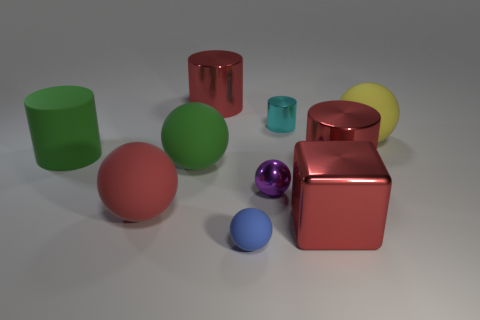Subtract 1 cylinders. How many cylinders are left? 3 Subtract all gray spheres. Subtract all green cylinders. How many spheres are left? 5 Subtract all cubes. How many objects are left? 9 Add 6 tiny gray matte objects. How many tiny gray matte objects exist? 6 Subtract 0 yellow blocks. How many objects are left? 10 Subtract all tiny red spheres. Subtract all red cylinders. How many objects are left? 8 Add 9 blue matte spheres. How many blue matte spheres are left? 10 